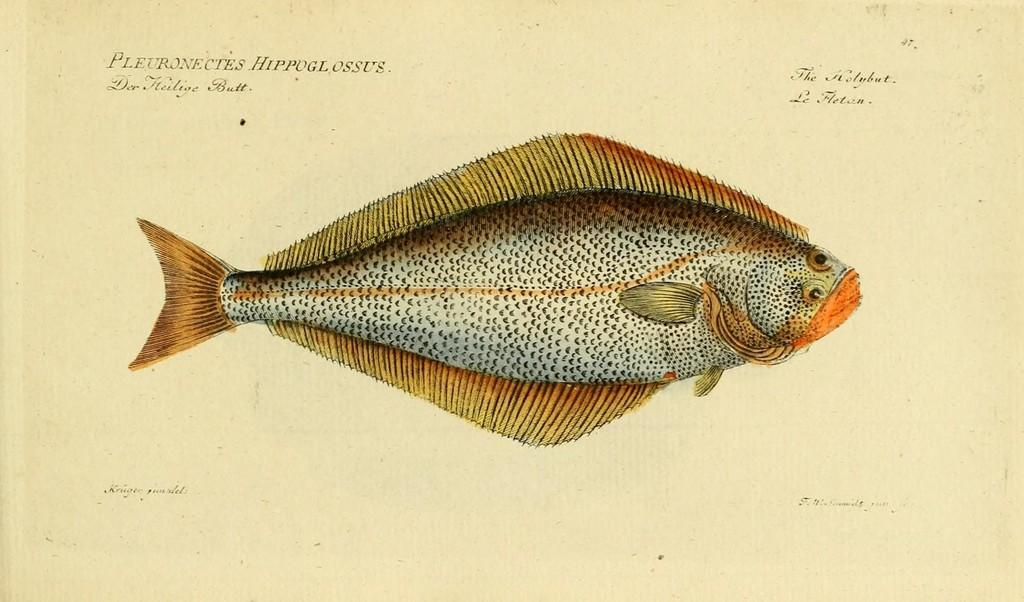What is the main subject in the center of the image? There is a fish in the center of the image. Where can text be found in the image? Text can be found in the top right, top left, bottom left, and bottom right corners of the image. What type of advertisement is being displayed in the image? There is no advertisement present in the image; it features a fish and text in the corners. Can you tell me how many homes are visible in the image? There are no homes visible in the image; it features a fish and text in the corners. 